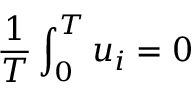<formula> <loc_0><loc_0><loc_500><loc_500>{ \frac { 1 } { T } } \int _ { 0 } ^ { T } u _ { i } = 0</formula> 